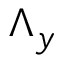Convert formula to latex. <formula><loc_0><loc_0><loc_500><loc_500>\Lambda _ { y }</formula> 